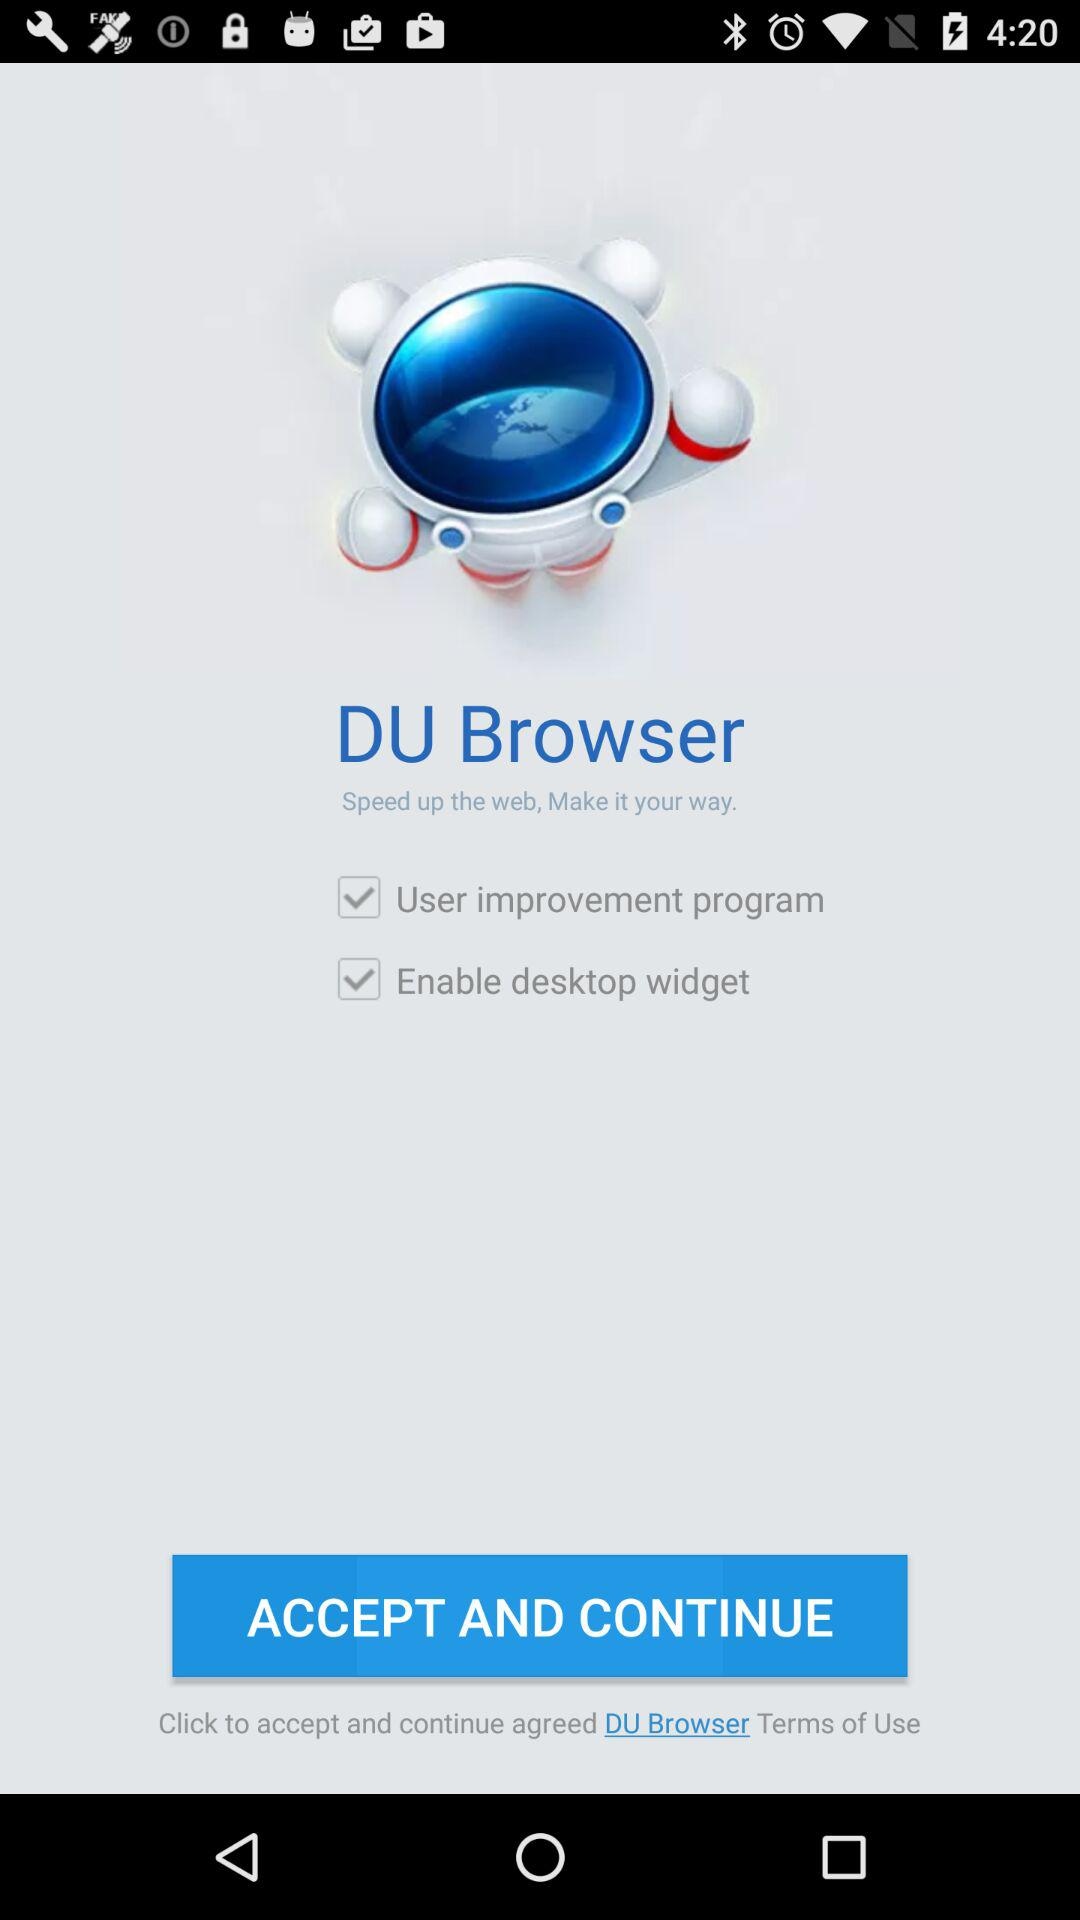What is the application name? The application name is "DU Browser". 